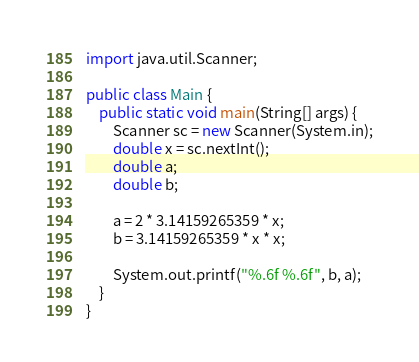Convert code to text. <code><loc_0><loc_0><loc_500><loc_500><_Java_>import java.util.Scanner;

public class Main {
	public static void main(String[] args) {
		Scanner sc = new Scanner(System.in);
		double x = sc.nextInt();
		double a;
		double b;

		a = 2 * 3.14159265359 * x;
		b = 3.14159265359 * x * x;

		System.out.printf("%.6f %.6f", b, a);
	}
}</code> 